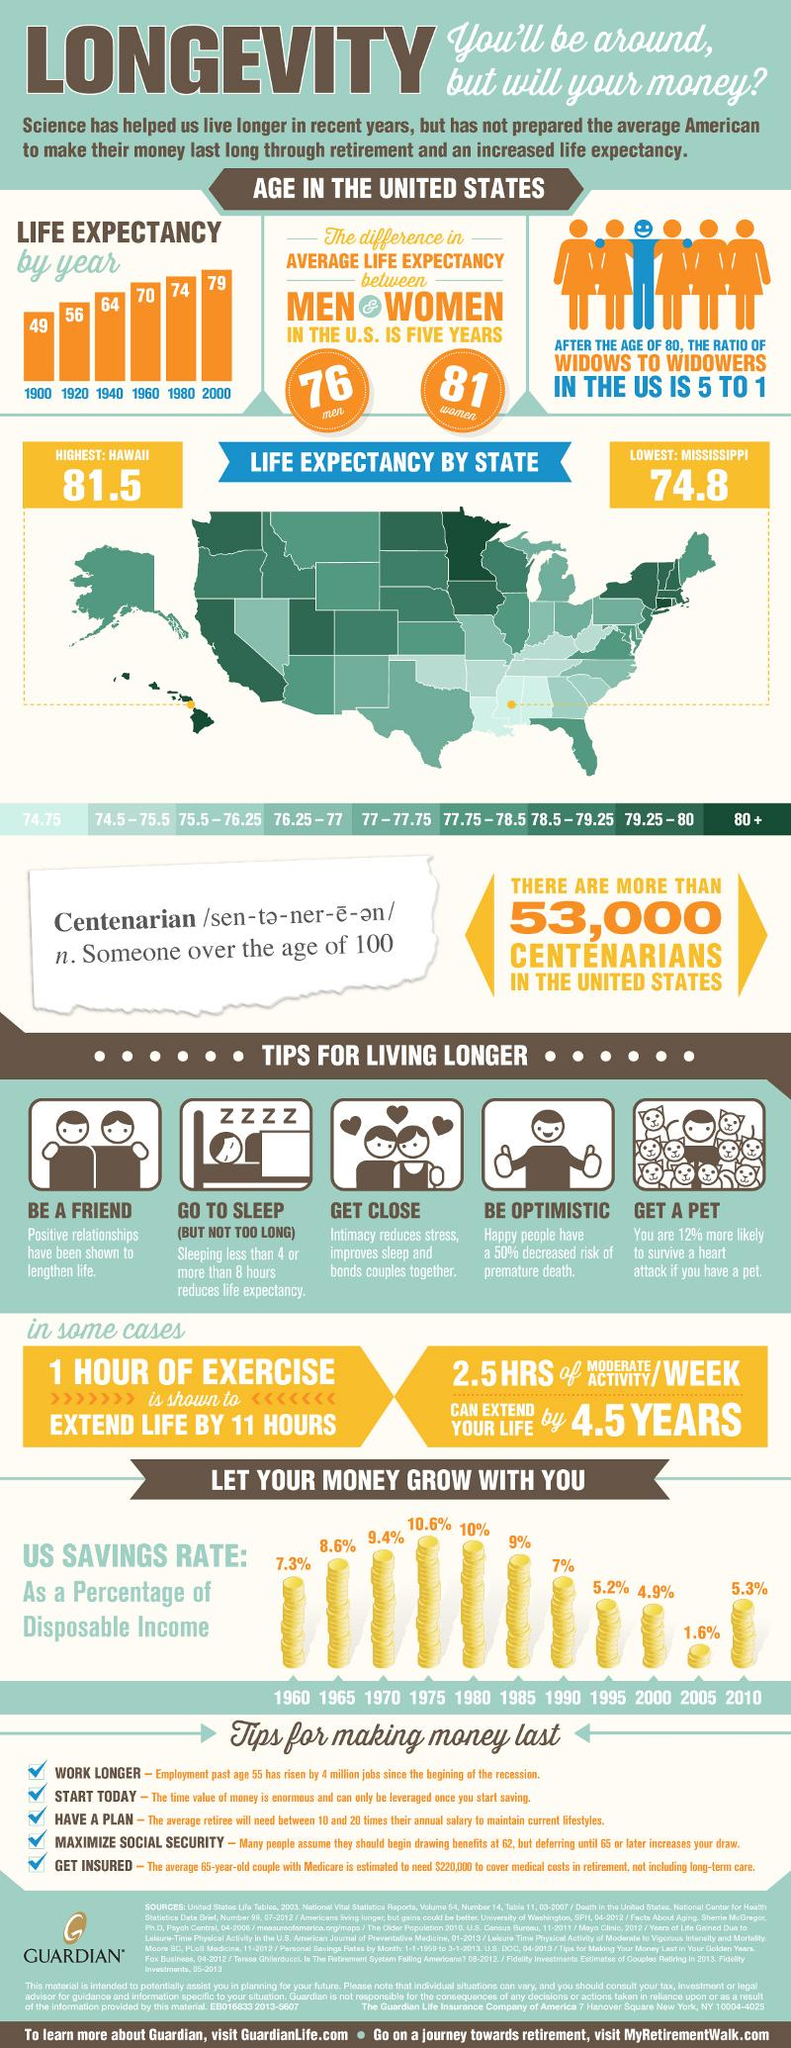Highlight a few significant elements in this photo. It is generally observed that women have a higher life expectancy than men. According to available data, three states have the lowest life expectancy. In 2000, life expectancy reached its highest point. According to data, approximately 53,000 people in the US have completed a century, which is a long-distance cycling event that involves riding a bicycle for 100 miles. 